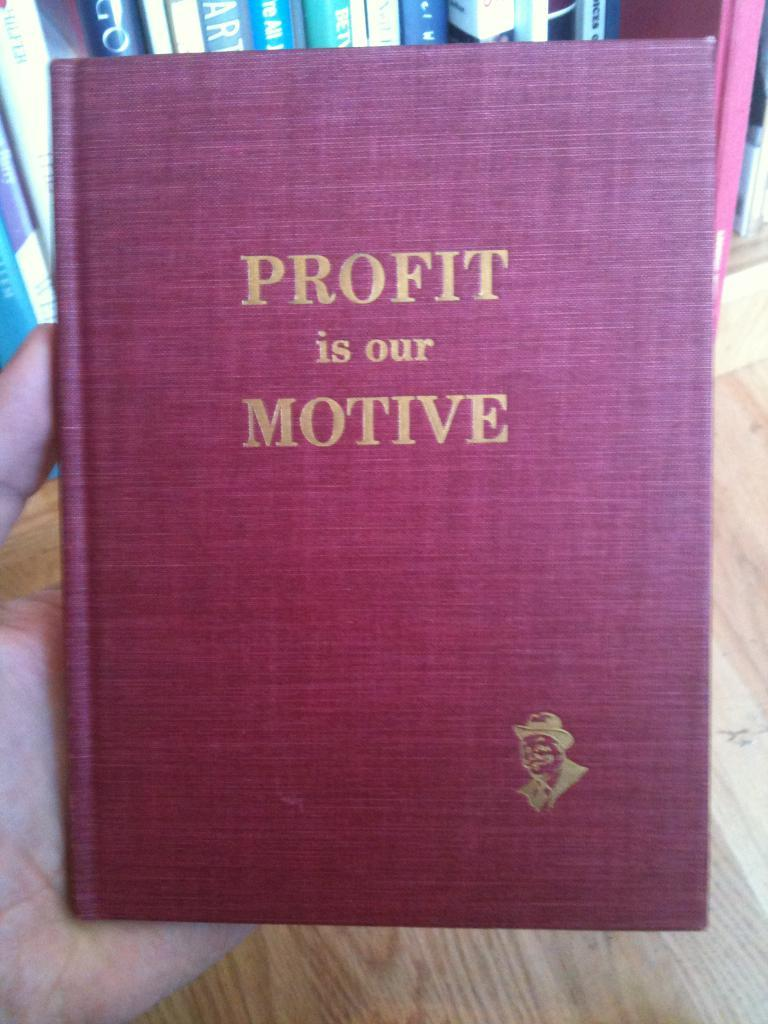<image>
Render a clear and concise summary of the photo. A red book titled "Profit is our Motive." 